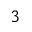Convert formula to latex. <formula><loc_0><loc_0><loc_500><loc_500>_ { 3 }</formula> 